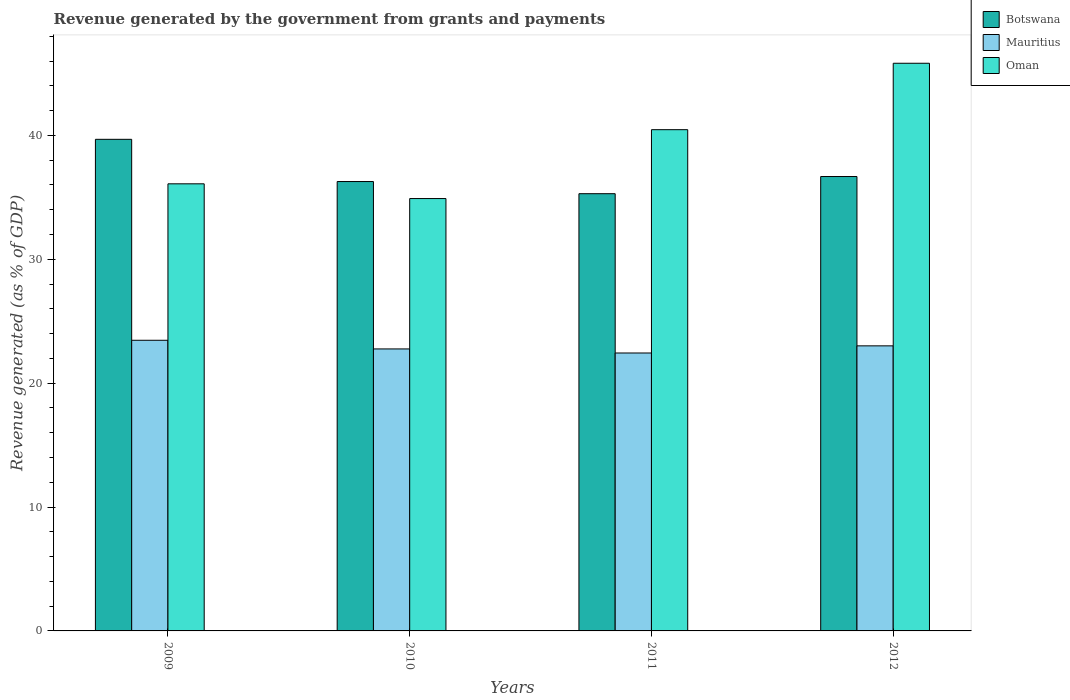How many different coloured bars are there?
Give a very brief answer. 3. Are the number of bars on each tick of the X-axis equal?
Offer a terse response. Yes. How many bars are there on the 1st tick from the right?
Ensure brevity in your answer.  3. What is the label of the 4th group of bars from the left?
Make the answer very short. 2012. In how many cases, is the number of bars for a given year not equal to the number of legend labels?
Ensure brevity in your answer.  0. What is the revenue generated by the government in Oman in 2012?
Make the answer very short. 45.82. Across all years, what is the maximum revenue generated by the government in Mauritius?
Make the answer very short. 23.46. Across all years, what is the minimum revenue generated by the government in Mauritius?
Your answer should be compact. 22.43. In which year was the revenue generated by the government in Botswana maximum?
Offer a terse response. 2009. In which year was the revenue generated by the government in Oman minimum?
Make the answer very short. 2010. What is the total revenue generated by the government in Mauritius in the graph?
Your response must be concise. 91.67. What is the difference between the revenue generated by the government in Oman in 2011 and that in 2012?
Offer a very short reply. -5.36. What is the difference between the revenue generated by the government in Oman in 2011 and the revenue generated by the government in Botswana in 2009?
Offer a very short reply. 0.78. What is the average revenue generated by the government in Botswana per year?
Give a very brief answer. 36.98. In the year 2009, what is the difference between the revenue generated by the government in Oman and revenue generated by the government in Botswana?
Ensure brevity in your answer.  -3.59. What is the ratio of the revenue generated by the government in Botswana in 2009 to that in 2010?
Your response must be concise. 1.09. What is the difference between the highest and the second highest revenue generated by the government in Botswana?
Keep it short and to the point. 3. What is the difference between the highest and the lowest revenue generated by the government in Botswana?
Give a very brief answer. 4.39. Is the sum of the revenue generated by the government in Oman in 2009 and 2010 greater than the maximum revenue generated by the government in Mauritius across all years?
Give a very brief answer. Yes. What does the 3rd bar from the left in 2009 represents?
Provide a short and direct response. Oman. What does the 3rd bar from the right in 2011 represents?
Your answer should be compact. Botswana. What is the difference between two consecutive major ticks on the Y-axis?
Your response must be concise. 10. Are the values on the major ticks of Y-axis written in scientific E-notation?
Provide a succinct answer. No. Does the graph contain any zero values?
Offer a terse response. No. Does the graph contain grids?
Offer a very short reply. No. Where does the legend appear in the graph?
Offer a very short reply. Top right. How many legend labels are there?
Ensure brevity in your answer.  3. How are the legend labels stacked?
Make the answer very short. Vertical. What is the title of the graph?
Provide a short and direct response. Revenue generated by the government from grants and payments. What is the label or title of the X-axis?
Provide a succinct answer. Years. What is the label or title of the Y-axis?
Make the answer very short. Revenue generated (as % of GDP). What is the Revenue generated (as % of GDP) of Botswana in 2009?
Offer a terse response. 39.68. What is the Revenue generated (as % of GDP) in Mauritius in 2009?
Your response must be concise. 23.46. What is the Revenue generated (as % of GDP) in Oman in 2009?
Your answer should be compact. 36.09. What is the Revenue generated (as % of GDP) in Botswana in 2010?
Provide a succinct answer. 36.27. What is the Revenue generated (as % of GDP) in Mauritius in 2010?
Make the answer very short. 22.76. What is the Revenue generated (as % of GDP) of Oman in 2010?
Offer a terse response. 34.9. What is the Revenue generated (as % of GDP) in Botswana in 2011?
Give a very brief answer. 35.29. What is the Revenue generated (as % of GDP) in Mauritius in 2011?
Give a very brief answer. 22.43. What is the Revenue generated (as % of GDP) in Oman in 2011?
Your answer should be compact. 40.46. What is the Revenue generated (as % of GDP) in Botswana in 2012?
Offer a terse response. 36.68. What is the Revenue generated (as % of GDP) in Mauritius in 2012?
Offer a very short reply. 23.01. What is the Revenue generated (as % of GDP) in Oman in 2012?
Offer a terse response. 45.82. Across all years, what is the maximum Revenue generated (as % of GDP) in Botswana?
Keep it short and to the point. 39.68. Across all years, what is the maximum Revenue generated (as % of GDP) of Mauritius?
Your answer should be compact. 23.46. Across all years, what is the maximum Revenue generated (as % of GDP) of Oman?
Your response must be concise. 45.82. Across all years, what is the minimum Revenue generated (as % of GDP) in Botswana?
Ensure brevity in your answer.  35.29. Across all years, what is the minimum Revenue generated (as % of GDP) in Mauritius?
Ensure brevity in your answer.  22.43. Across all years, what is the minimum Revenue generated (as % of GDP) of Oman?
Provide a short and direct response. 34.9. What is the total Revenue generated (as % of GDP) in Botswana in the graph?
Ensure brevity in your answer.  147.92. What is the total Revenue generated (as % of GDP) of Mauritius in the graph?
Ensure brevity in your answer.  91.67. What is the total Revenue generated (as % of GDP) in Oman in the graph?
Your answer should be very brief. 157.27. What is the difference between the Revenue generated (as % of GDP) in Botswana in 2009 and that in 2010?
Offer a terse response. 3.41. What is the difference between the Revenue generated (as % of GDP) in Mauritius in 2009 and that in 2010?
Give a very brief answer. 0.7. What is the difference between the Revenue generated (as % of GDP) of Oman in 2009 and that in 2010?
Your answer should be compact. 1.19. What is the difference between the Revenue generated (as % of GDP) of Botswana in 2009 and that in 2011?
Provide a succinct answer. 4.39. What is the difference between the Revenue generated (as % of GDP) in Mauritius in 2009 and that in 2011?
Your answer should be compact. 1.03. What is the difference between the Revenue generated (as % of GDP) in Oman in 2009 and that in 2011?
Ensure brevity in your answer.  -4.37. What is the difference between the Revenue generated (as % of GDP) of Botswana in 2009 and that in 2012?
Offer a terse response. 3. What is the difference between the Revenue generated (as % of GDP) in Mauritius in 2009 and that in 2012?
Keep it short and to the point. 0.45. What is the difference between the Revenue generated (as % of GDP) in Oman in 2009 and that in 2012?
Ensure brevity in your answer.  -9.73. What is the difference between the Revenue generated (as % of GDP) of Botswana in 2010 and that in 2011?
Your response must be concise. 0.98. What is the difference between the Revenue generated (as % of GDP) in Mauritius in 2010 and that in 2011?
Give a very brief answer. 0.33. What is the difference between the Revenue generated (as % of GDP) in Oman in 2010 and that in 2011?
Your answer should be very brief. -5.56. What is the difference between the Revenue generated (as % of GDP) of Botswana in 2010 and that in 2012?
Provide a short and direct response. -0.41. What is the difference between the Revenue generated (as % of GDP) in Mauritius in 2010 and that in 2012?
Your response must be concise. -0.25. What is the difference between the Revenue generated (as % of GDP) in Oman in 2010 and that in 2012?
Ensure brevity in your answer.  -10.92. What is the difference between the Revenue generated (as % of GDP) of Botswana in 2011 and that in 2012?
Give a very brief answer. -1.39. What is the difference between the Revenue generated (as % of GDP) of Mauritius in 2011 and that in 2012?
Your answer should be compact. -0.58. What is the difference between the Revenue generated (as % of GDP) in Oman in 2011 and that in 2012?
Ensure brevity in your answer.  -5.36. What is the difference between the Revenue generated (as % of GDP) of Botswana in 2009 and the Revenue generated (as % of GDP) of Mauritius in 2010?
Give a very brief answer. 16.92. What is the difference between the Revenue generated (as % of GDP) in Botswana in 2009 and the Revenue generated (as % of GDP) in Oman in 2010?
Offer a very short reply. 4.78. What is the difference between the Revenue generated (as % of GDP) in Mauritius in 2009 and the Revenue generated (as % of GDP) in Oman in 2010?
Your response must be concise. -11.44. What is the difference between the Revenue generated (as % of GDP) of Botswana in 2009 and the Revenue generated (as % of GDP) of Mauritius in 2011?
Offer a very short reply. 17.25. What is the difference between the Revenue generated (as % of GDP) in Botswana in 2009 and the Revenue generated (as % of GDP) in Oman in 2011?
Your response must be concise. -0.78. What is the difference between the Revenue generated (as % of GDP) of Mauritius in 2009 and the Revenue generated (as % of GDP) of Oman in 2011?
Provide a short and direct response. -17. What is the difference between the Revenue generated (as % of GDP) in Botswana in 2009 and the Revenue generated (as % of GDP) in Mauritius in 2012?
Offer a terse response. 16.67. What is the difference between the Revenue generated (as % of GDP) in Botswana in 2009 and the Revenue generated (as % of GDP) in Oman in 2012?
Your response must be concise. -6.14. What is the difference between the Revenue generated (as % of GDP) in Mauritius in 2009 and the Revenue generated (as % of GDP) in Oman in 2012?
Ensure brevity in your answer.  -22.36. What is the difference between the Revenue generated (as % of GDP) in Botswana in 2010 and the Revenue generated (as % of GDP) in Mauritius in 2011?
Your answer should be compact. 13.84. What is the difference between the Revenue generated (as % of GDP) of Botswana in 2010 and the Revenue generated (as % of GDP) of Oman in 2011?
Your answer should be compact. -4.19. What is the difference between the Revenue generated (as % of GDP) of Mauritius in 2010 and the Revenue generated (as % of GDP) of Oman in 2011?
Ensure brevity in your answer.  -17.7. What is the difference between the Revenue generated (as % of GDP) of Botswana in 2010 and the Revenue generated (as % of GDP) of Mauritius in 2012?
Your answer should be very brief. 13.26. What is the difference between the Revenue generated (as % of GDP) of Botswana in 2010 and the Revenue generated (as % of GDP) of Oman in 2012?
Make the answer very short. -9.55. What is the difference between the Revenue generated (as % of GDP) of Mauritius in 2010 and the Revenue generated (as % of GDP) of Oman in 2012?
Make the answer very short. -23.06. What is the difference between the Revenue generated (as % of GDP) in Botswana in 2011 and the Revenue generated (as % of GDP) in Mauritius in 2012?
Provide a short and direct response. 12.28. What is the difference between the Revenue generated (as % of GDP) in Botswana in 2011 and the Revenue generated (as % of GDP) in Oman in 2012?
Your answer should be compact. -10.53. What is the difference between the Revenue generated (as % of GDP) in Mauritius in 2011 and the Revenue generated (as % of GDP) in Oman in 2012?
Provide a short and direct response. -23.39. What is the average Revenue generated (as % of GDP) in Botswana per year?
Your response must be concise. 36.98. What is the average Revenue generated (as % of GDP) in Mauritius per year?
Your answer should be compact. 22.92. What is the average Revenue generated (as % of GDP) in Oman per year?
Give a very brief answer. 39.32. In the year 2009, what is the difference between the Revenue generated (as % of GDP) in Botswana and Revenue generated (as % of GDP) in Mauritius?
Provide a succinct answer. 16.22. In the year 2009, what is the difference between the Revenue generated (as % of GDP) of Botswana and Revenue generated (as % of GDP) of Oman?
Keep it short and to the point. 3.59. In the year 2009, what is the difference between the Revenue generated (as % of GDP) in Mauritius and Revenue generated (as % of GDP) in Oman?
Your answer should be compact. -12.63. In the year 2010, what is the difference between the Revenue generated (as % of GDP) in Botswana and Revenue generated (as % of GDP) in Mauritius?
Provide a succinct answer. 13.51. In the year 2010, what is the difference between the Revenue generated (as % of GDP) in Botswana and Revenue generated (as % of GDP) in Oman?
Offer a terse response. 1.37. In the year 2010, what is the difference between the Revenue generated (as % of GDP) in Mauritius and Revenue generated (as % of GDP) in Oman?
Provide a short and direct response. -12.14. In the year 2011, what is the difference between the Revenue generated (as % of GDP) of Botswana and Revenue generated (as % of GDP) of Mauritius?
Ensure brevity in your answer.  12.86. In the year 2011, what is the difference between the Revenue generated (as % of GDP) in Botswana and Revenue generated (as % of GDP) in Oman?
Provide a short and direct response. -5.17. In the year 2011, what is the difference between the Revenue generated (as % of GDP) in Mauritius and Revenue generated (as % of GDP) in Oman?
Make the answer very short. -18.03. In the year 2012, what is the difference between the Revenue generated (as % of GDP) of Botswana and Revenue generated (as % of GDP) of Mauritius?
Provide a succinct answer. 13.67. In the year 2012, what is the difference between the Revenue generated (as % of GDP) of Botswana and Revenue generated (as % of GDP) of Oman?
Offer a terse response. -9.14. In the year 2012, what is the difference between the Revenue generated (as % of GDP) of Mauritius and Revenue generated (as % of GDP) of Oman?
Provide a succinct answer. -22.81. What is the ratio of the Revenue generated (as % of GDP) of Botswana in 2009 to that in 2010?
Give a very brief answer. 1.09. What is the ratio of the Revenue generated (as % of GDP) of Mauritius in 2009 to that in 2010?
Your answer should be very brief. 1.03. What is the ratio of the Revenue generated (as % of GDP) of Oman in 2009 to that in 2010?
Your answer should be compact. 1.03. What is the ratio of the Revenue generated (as % of GDP) in Botswana in 2009 to that in 2011?
Keep it short and to the point. 1.12. What is the ratio of the Revenue generated (as % of GDP) in Mauritius in 2009 to that in 2011?
Give a very brief answer. 1.05. What is the ratio of the Revenue generated (as % of GDP) of Oman in 2009 to that in 2011?
Your answer should be very brief. 0.89. What is the ratio of the Revenue generated (as % of GDP) of Botswana in 2009 to that in 2012?
Keep it short and to the point. 1.08. What is the ratio of the Revenue generated (as % of GDP) of Mauritius in 2009 to that in 2012?
Your answer should be very brief. 1.02. What is the ratio of the Revenue generated (as % of GDP) of Oman in 2009 to that in 2012?
Offer a very short reply. 0.79. What is the ratio of the Revenue generated (as % of GDP) of Botswana in 2010 to that in 2011?
Offer a terse response. 1.03. What is the ratio of the Revenue generated (as % of GDP) in Mauritius in 2010 to that in 2011?
Your response must be concise. 1.01. What is the ratio of the Revenue generated (as % of GDP) in Oman in 2010 to that in 2011?
Offer a very short reply. 0.86. What is the ratio of the Revenue generated (as % of GDP) of Mauritius in 2010 to that in 2012?
Your response must be concise. 0.99. What is the ratio of the Revenue generated (as % of GDP) of Oman in 2010 to that in 2012?
Ensure brevity in your answer.  0.76. What is the ratio of the Revenue generated (as % of GDP) of Botswana in 2011 to that in 2012?
Provide a succinct answer. 0.96. What is the ratio of the Revenue generated (as % of GDP) in Mauritius in 2011 to that in 2012?
Provide a short and direct response. 0.97. What is the ratio of the Revenue generated (as % of GDP) in Oman in 2011 to that in 2012?
Offer a very short reply. 0.88. What is the difference between the highest and the second highest Revenue generated (as % of GDP) of Botswana?
Your answer should be very brief. 3. What is the difference between the highest and the second highest Revenue generated (as % of GDP) of Mauritius?
Keep it short and to the point. 0.45. What is the difference between the highest and the second highest Revenue generated (as % of GDP) in Oman?
Your response must be concise. 5.36. What is the difference between the highest and the lowest Revenue generated (as % of GDP) of Botswana?
Give a very brief answer. 4.39. What is the difference between the highest and the lowest Revenue generated (as % of GDP) in Mauritius?
Make the answer very short. 1.03. What is the difference between the highest and the lowest Revenue generated (as % of GDP) in Oman?
Offer a very short reply. 10.92. 